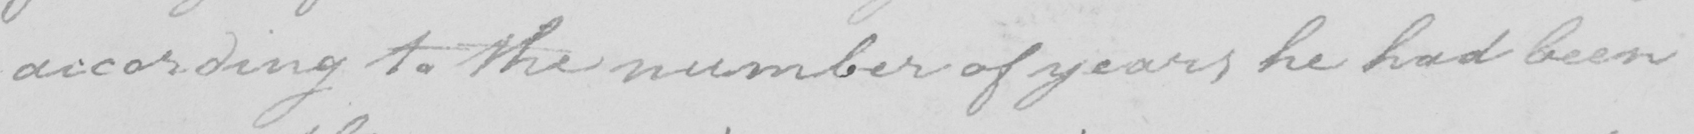What does this handwritten line say? according to the number of years he had been 